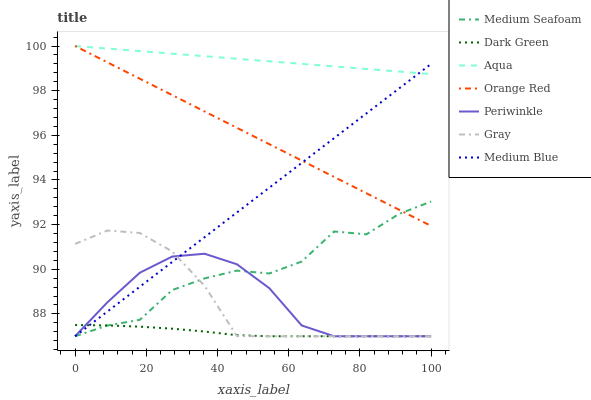Does Medium Blue have the minimum area under the curve?
Answer yes or no. No. Does Medium Blue have the maximum area under the curve?
Answer yes or no. No. Is Aqua the smoothest?
Answer yes or no. No. Is Aqua the roughest?
Answer yes or no. No. Does Aqua have the lowest value?
Answer yes or no. No. Does Medium Blue have the highest value?
Answer yes or no. No. Is Dark Green less than Orange Red?
Answer yes or no. Yes. Is Orange Red greater than Periwinkle?
Answer yes or no. Yes. Does Dark Green intersect Orange Red?
Answer yes or no. No. 